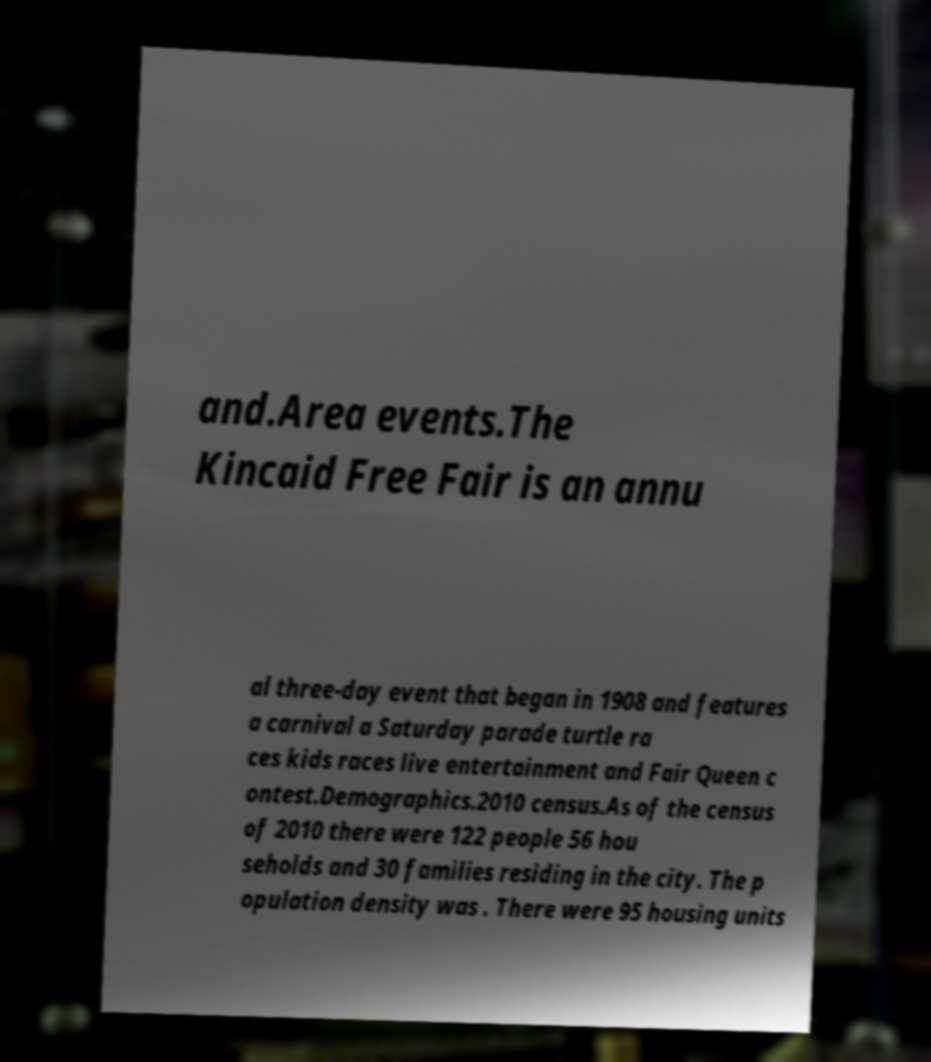Please identify and transcribe the text found in this image. and.Area events.The Kincaid Free Fair is an annu al three-day event that began in 1908 and features a carnival a Saturday parade turtle ra ces kids races live entertainment and Fair Queen c ontest.Demographics.2010 census.As of the census of 2010 there were 122 people 56 hou seholds and 30 families residing in the city. The p opulation density was . There were 95 housing units 